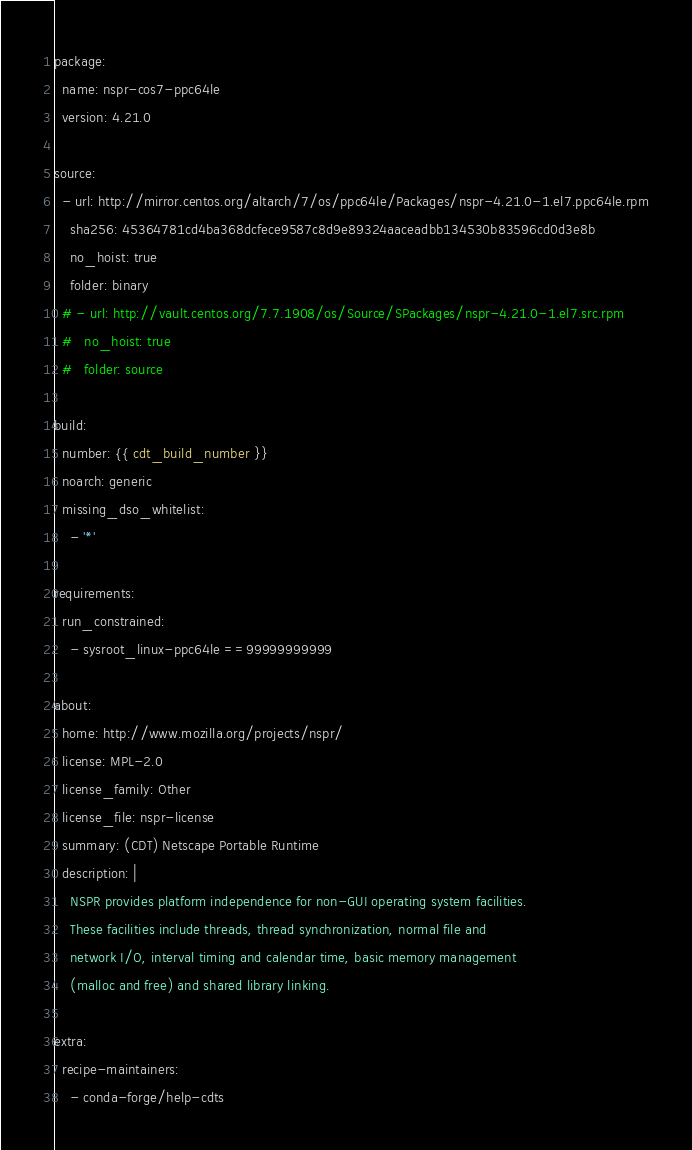<code> <loc_0><loc_0><loc_500><loc_500><_YAML_>package:
  name: nspr-cos7-ppc64le
  version: 4.21.0

source:
  - url: http://mirror.centos.org/altarch/7/os/ppc64le/Packages/nspr-4.21.0-1.el7.ppc64le.rpm
    sha256: 45364781cd4ba368dcfece9587c8d9e89324aaceadbb134530b83596cd0d3e8b
    no_hoist: true
    folder: binary
  # - url: http://vault.centos.org/7.7.1908/os/Source/SPackages/nspr-4.21.0-1.el7.src.rpm
  #   no_hoist: true
  #   folder: source

build:
  number: {{ cdt_build_number }}
  noarch: generic
  missing_dso_whitelist:
    - '*'

requirements:
  run_constrained:
    - sysroot_linux-ppc64le ==99999999999

about:
  home: http://www.mozilla.org/projects/nspr/
  license: MPL-2.0
  license_family: Other
  license_file: nspr-license
  summary: (CDT) Netscape Portable Runtime
  description: |
    NSPR provides platform independence for non-GUI operating system facilities.
    These facilities include threads, thread synchronization, normal file and
    network I/O, interval timing and calendar time, basic memory management
    (malloc and free) and shared library linking.

extra:
  recipe-maintainers:
    - conda-forge/help-cdts
</code> 